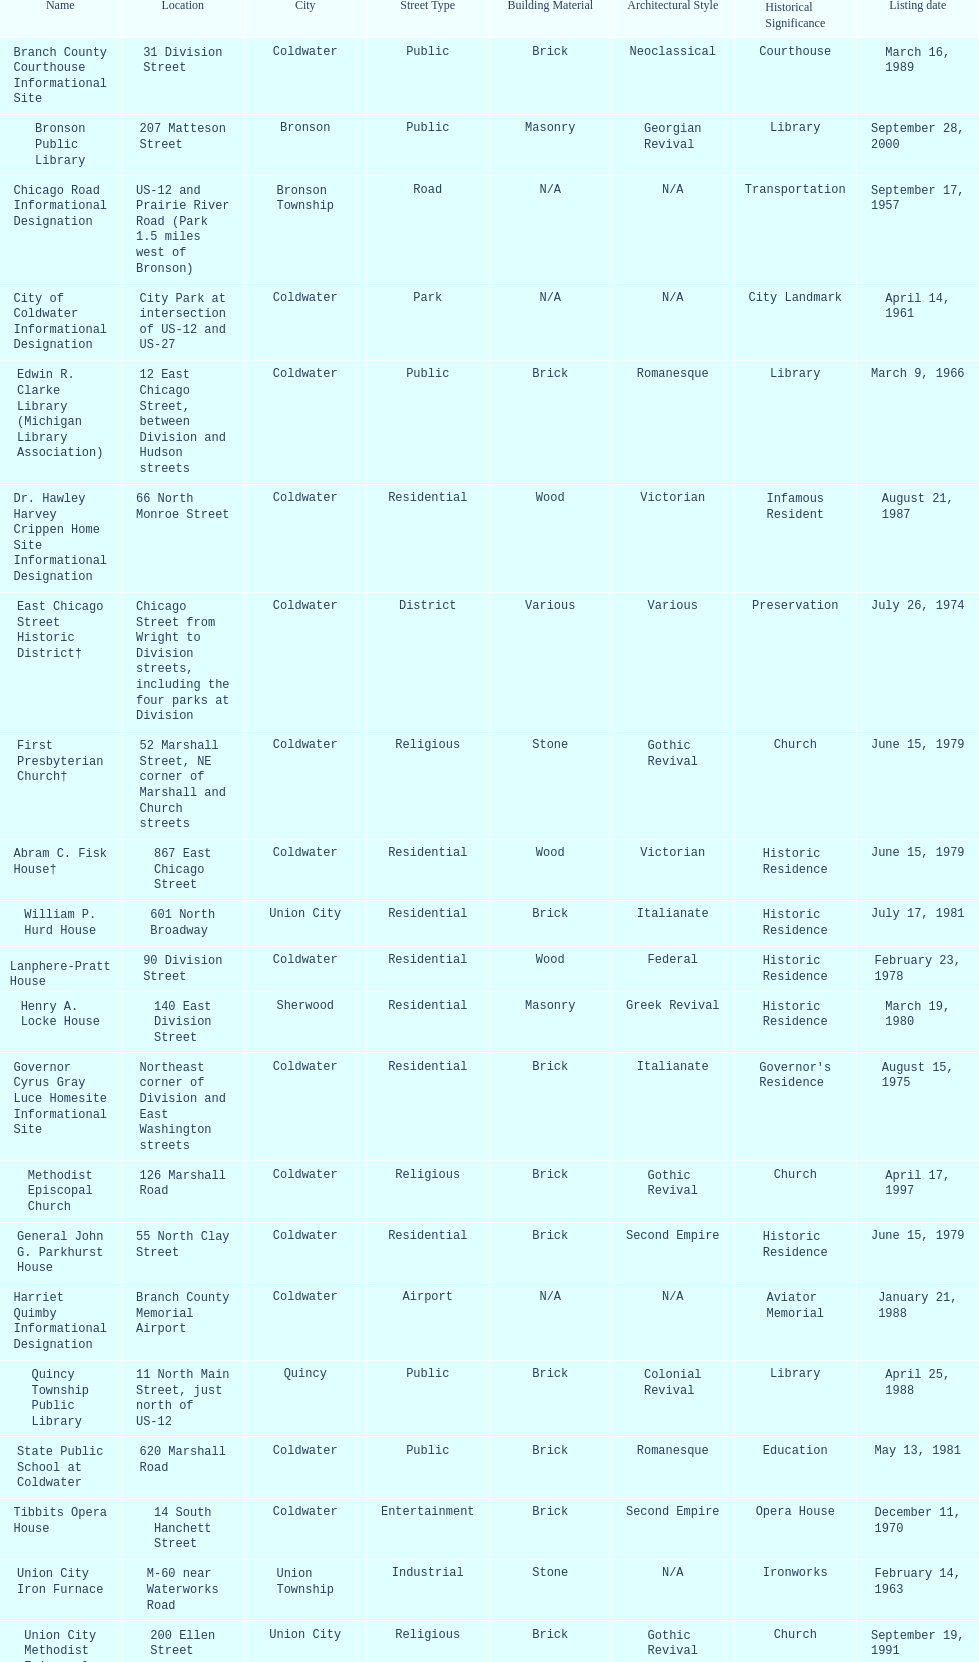What is the name with the only listing date on april 14, 1961 City of Coldwater. 